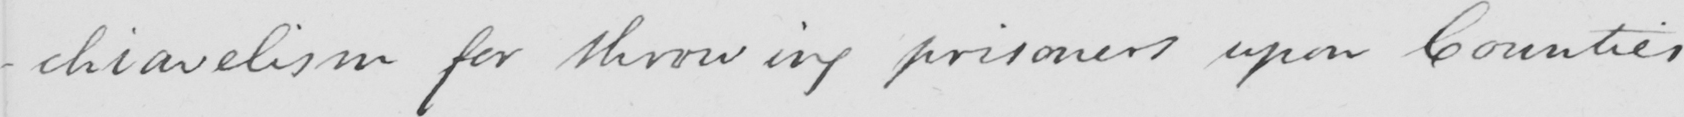Can you read and transcribe this handwriting? -chiavelism for throwing prisoners upon Counties 